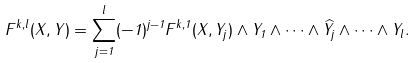Convert formula to latex. <formula><loc_0><loc_0><loc_500><loc_500>F ^ { k , l } ( X , Y ) = \sum _ { j = 1 } ^ { l } ( - 1 ) ^ { j - 1 } F ^ { k , 1 } ( X , Y _ { j } ) \wedge Y _ { 1 } \wedge \cdots \wedge \widehat { Y _ { j } } \wedge \cdots \wedge Y _ { l } .</formula> 